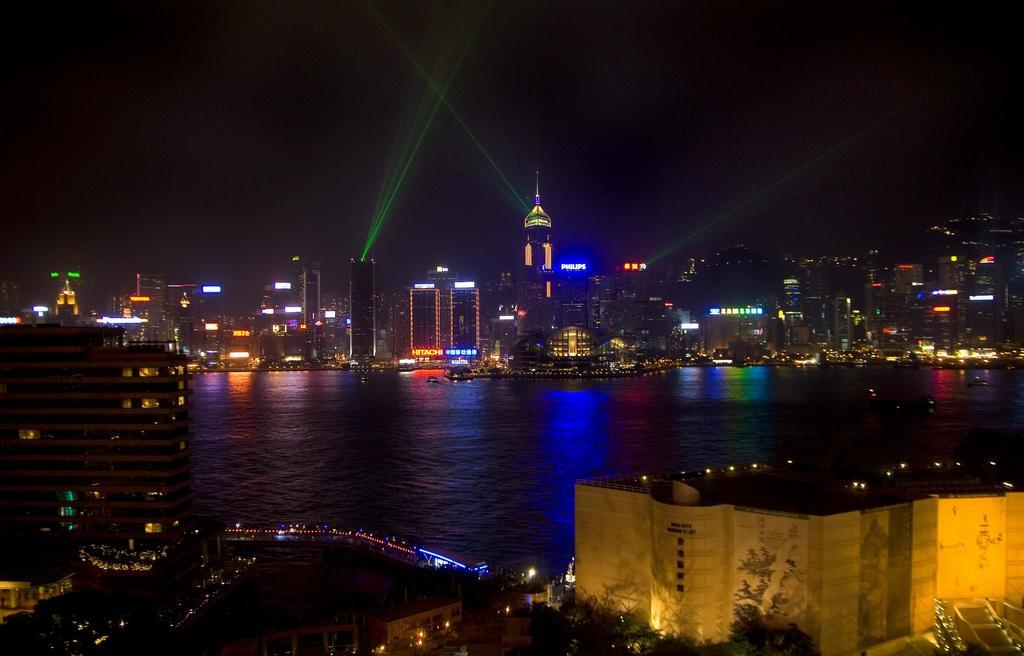What is the primary element visible in the image? There is water in the image. What type of structures can be seen in the image? There are buildings with lights in the image. What type of vegetation is present in the image? There are trees in the image. What is happening in the sky in the image? There is lighting in the sky in the image. Can you see a snake slithering through the water in the image? There is no snake present in the image; it only features water, buildings with lights, trees, and lighting in the sky. How many times does the building sneeze in the image? Buildings do not sneeze, so this question cannot be answered. 